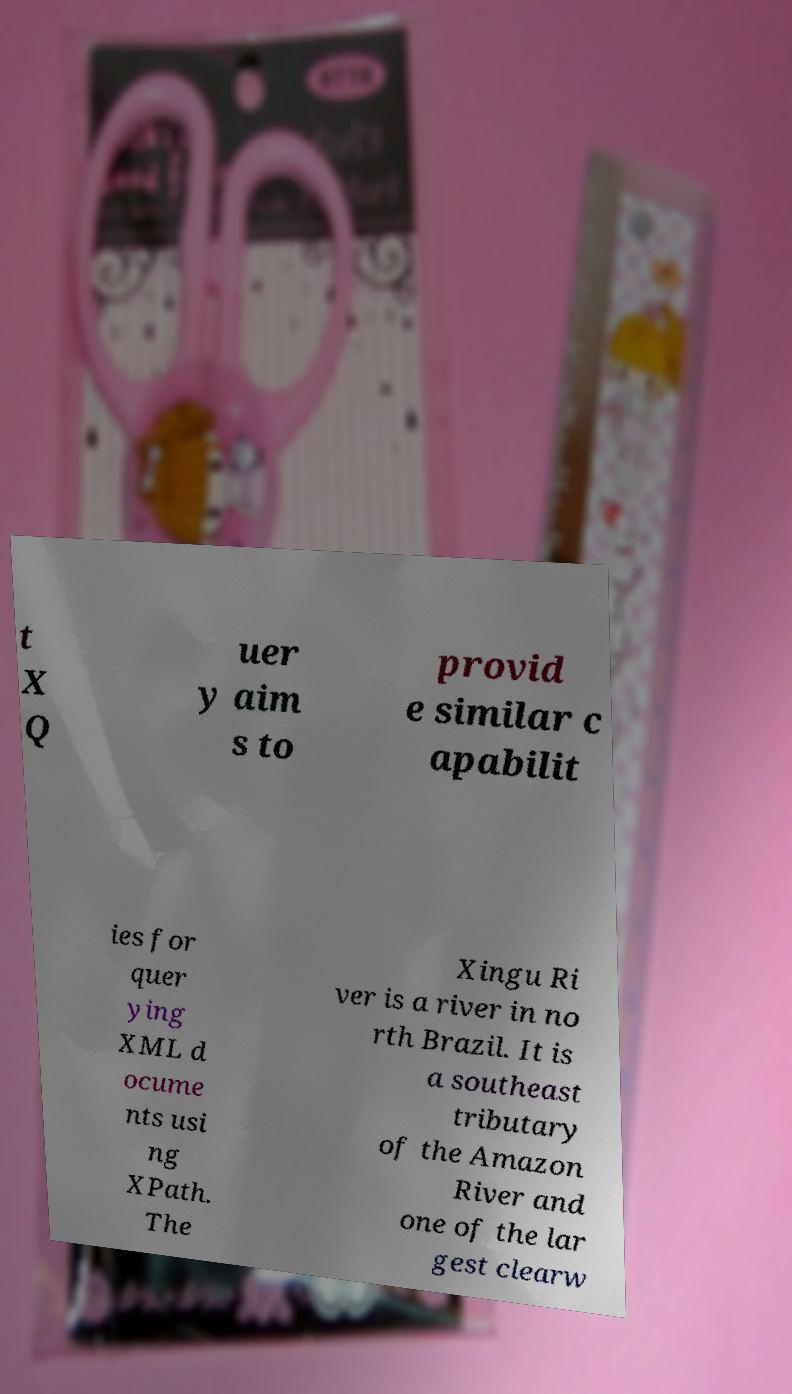Could you extract and type out the text from this image? t X Q uer y aim s to provid e similar c apabilit ies for quer ying XML d ocume nts usi ng XPath. The Xingu Ri ver is a river in no rth Brazil. It is a southeast tributary of the Amazon River and one of the lar gest clearw 